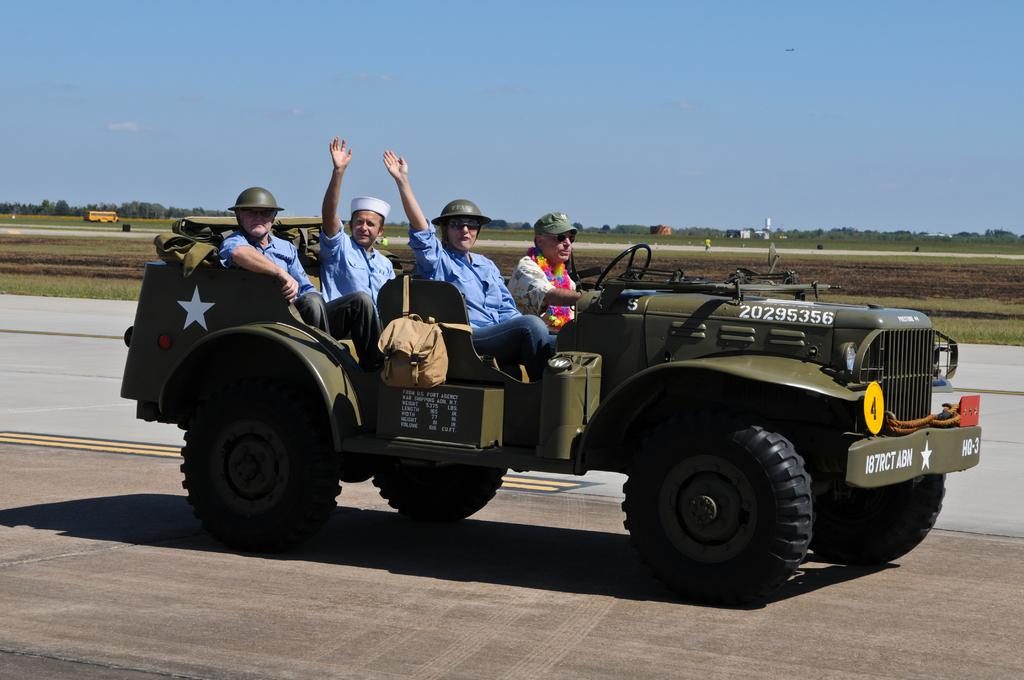What are the people in the image doing? The people are sitting in a vehicle. What can be seen inside the vehicle? There are bags visible in the image. What is the setting of the image? There is a road, grass, and trees in the background of the image. Can you describe the other vehicle in the background? There is another vehicle in the background of the image. What else is visible in the background? There are objects and the sky visible in the background of the image. Can you tell me how many horses are running alongside the vehicle in the image? There are no horses present in the image; it features people sitting in a vehicle with a road, grass, trees, and another vehicle in the background. 